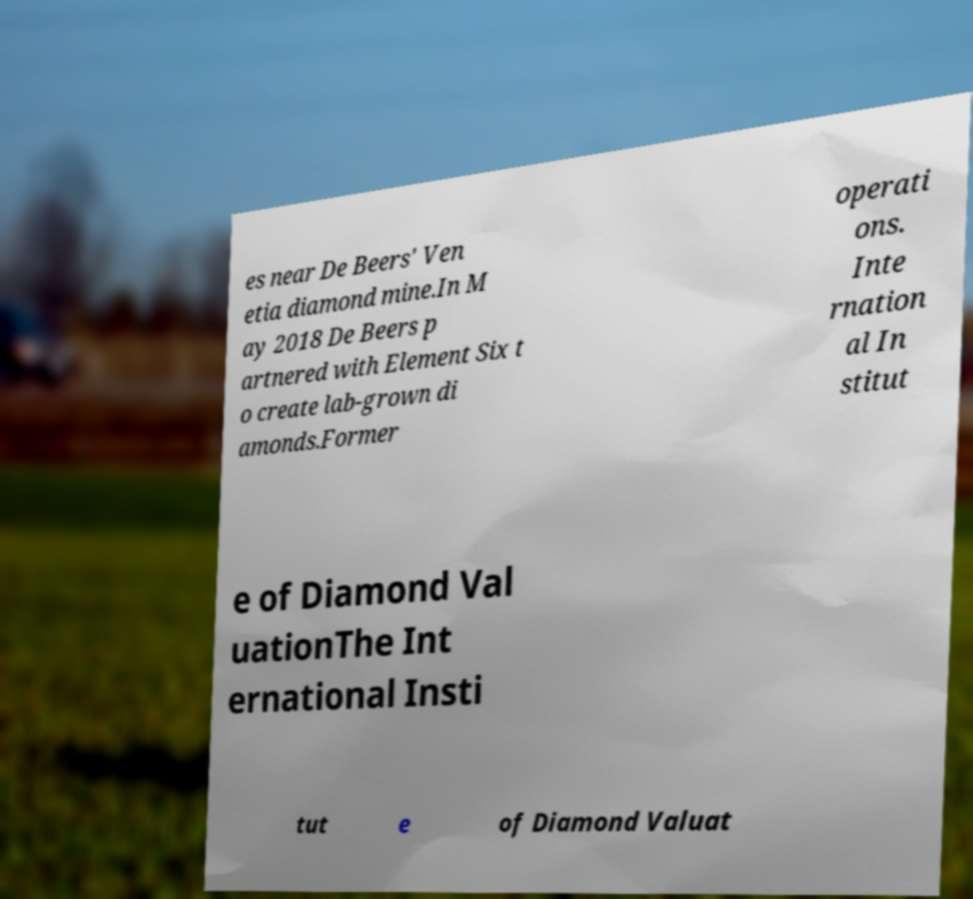Could you assist in decoding the text presented in this image and type it out clearly? es near De Beers' Ven etia diamond mine.In M ay 2018 De Beers p artnered with Element Six t o create lab-grown di amonds.Former operati ons. Inte rnation al In stitut e of Diamond Val uationThe Int ernational Insti tut e of Diamond Valuat 